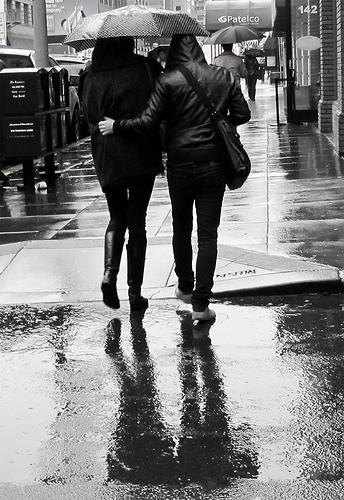What relationship do the persons sharing the umbrella have? Please explain your reasoning. intimate. The people are standing close together. one person has their arm around the other. 